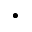Convert formula to latex. <formula><loc_0><loc_0><loc_500><loc_500>\bullet</formula> 